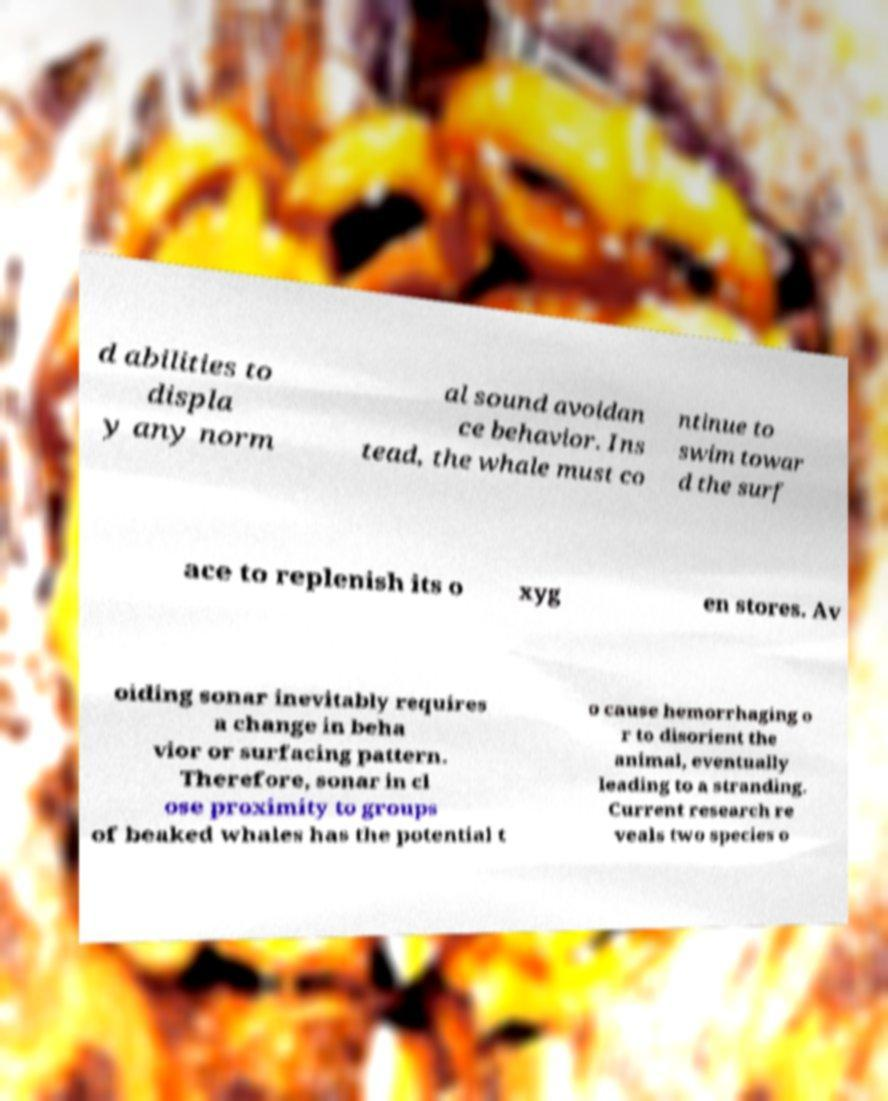For documentation purposes, I need the text within this image transcribed. Could you provide that? d abilities to displa y any norm al sound avoidan ce behavior. Ins tead, the whale must co ntinue to swim towar d the surf ace to replenish its o xyg en stores. Av oiding sonar inevitably requires a change in beha vior or surfacing pattern. Therefore, sonar in cl ose proximity to groups of beaked whales has the potential t o cause hemorrhaging o r to disorient the animal, eventually leading to a stranding. Current research re veals two species o 